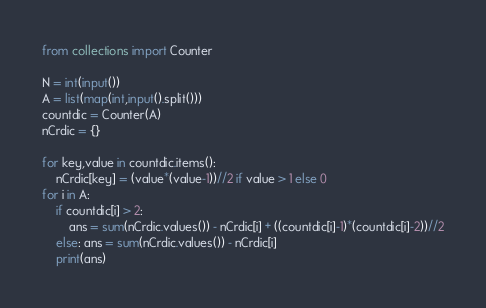Convert code to text. <code><loc_0><loc_0><loc_500><loc_500><_Python_>from collections import Counter

N = int(input())
A = list(map(int,input().split()))
countdic = Counter(A)
nCrdic = {}

for key,value in countdic.items():
    nCrdic[key] = (value*(value-1))//2 if value > 1 else 0
for i in A:
    if countdic[i] > 2:
        ans = sum(nCrdic.values()) - nCrdic[i] + ((countdic[i]-1)*(countdic[i]-2))//2
    else: ans = sum(nCrdic.values()) - nCrdic[i]
    print(ans)</code> 